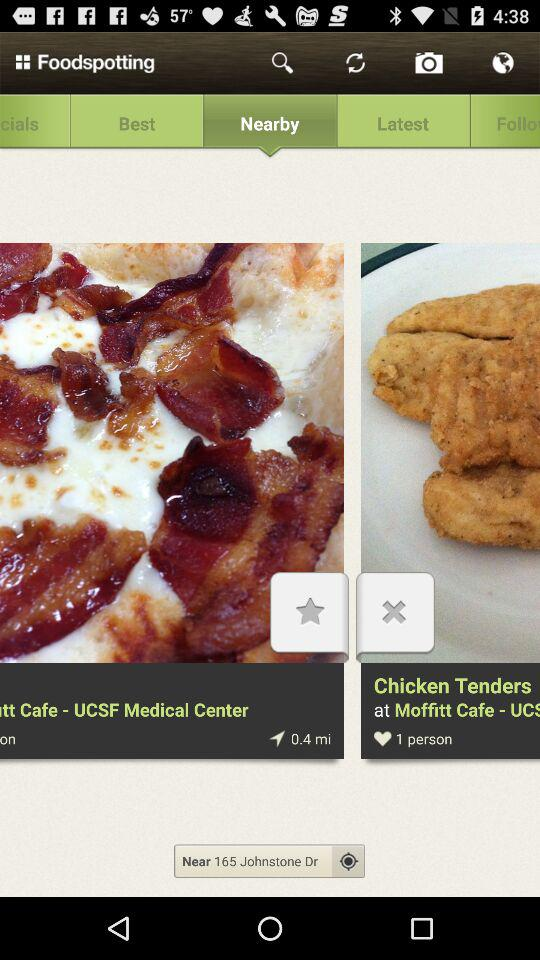What is the location? The location is 165 Johnstone Dr. 